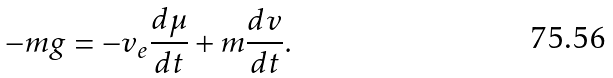Convert formula to latex. <formula><loc_0><loc_0><loc_500><loc_500>- m g = - v _ { e } \frac { d \mu } { d t } + m \frac { d v } { d t } .</formula> 